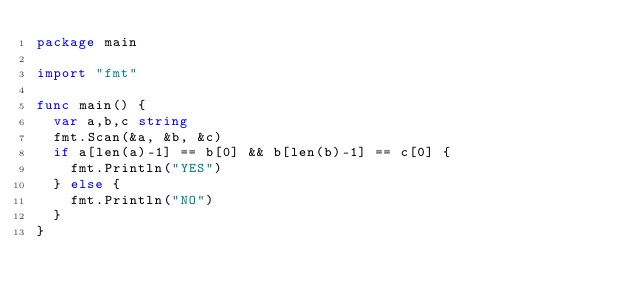Convert code to text. <code><loc_0><loc_0><loc_500><loc_500><_Go_>package main

import "fmt"

func main() {
	var a,b,c string
	fmt.Scan(&a, &b, &c)
	if a[len(a)-1] == b[0] && b[len(b)-1] == c[0] {
		fmt.Println("YES")
	} else {
		fmt.Println("NO")
	}
}
</code> 